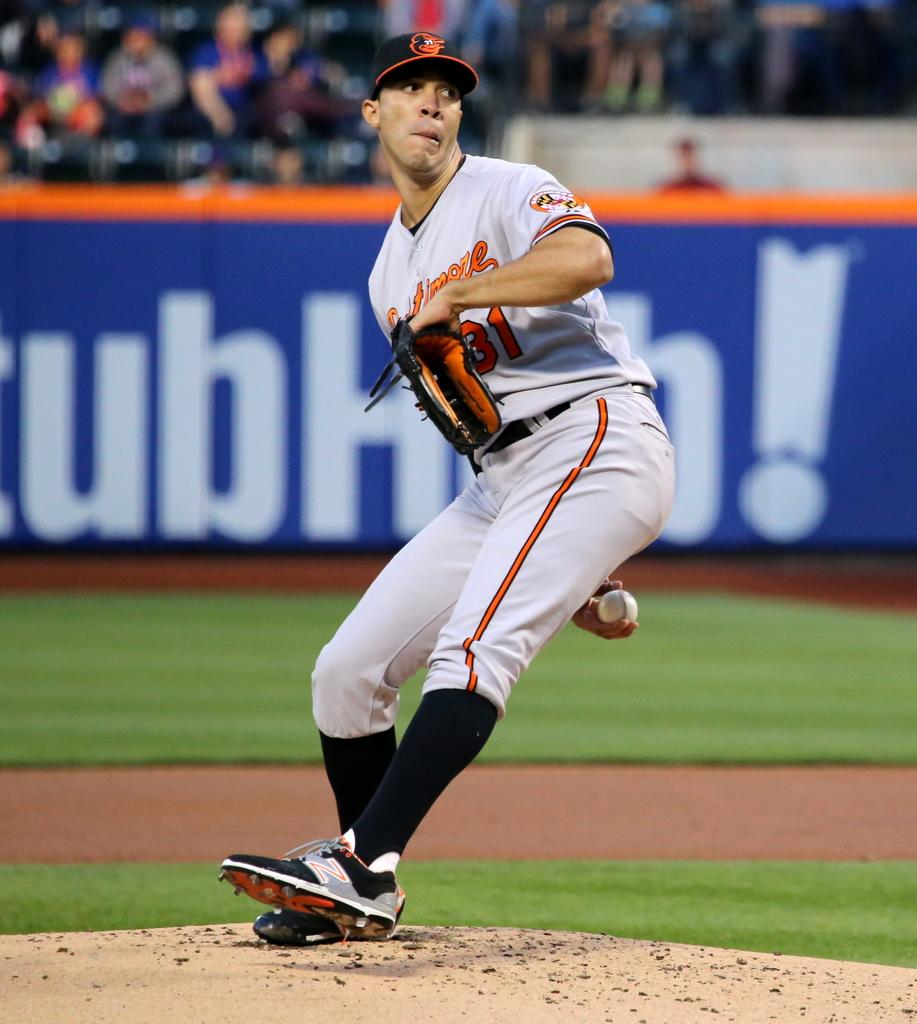<image>
Provide a brief description of the given image. A baseball pitcher is winding up a pitch and his uniform says Baltimore. 